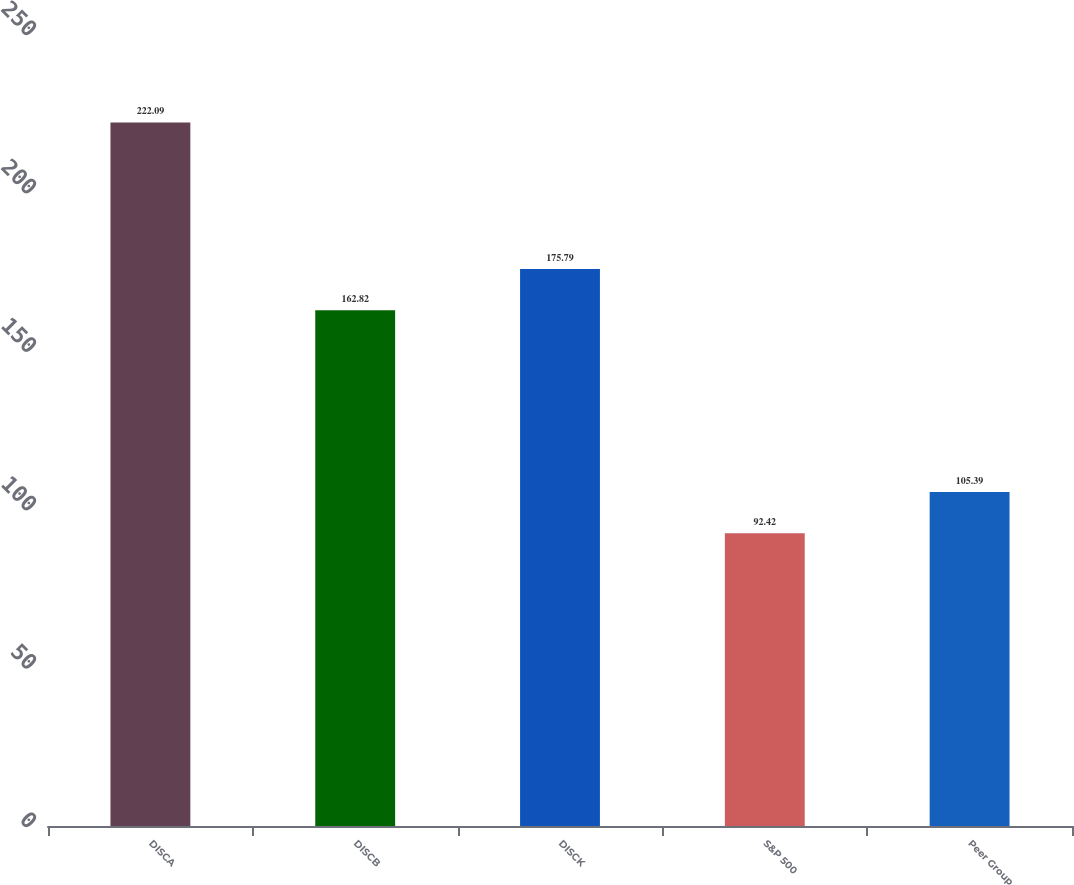Convert chart. <chart><loc_0><loc_0><loc_500><loc_500><bar_chart><fcel>DISCA<fcel>DISCB<fcel>DISCK<fcel>S&P 500<fcel>Peer Group<nl><fcel>222.09<fcel>162.82<fcel>175.79<fcel>92.42<fcel>105.39<nl></chart> 